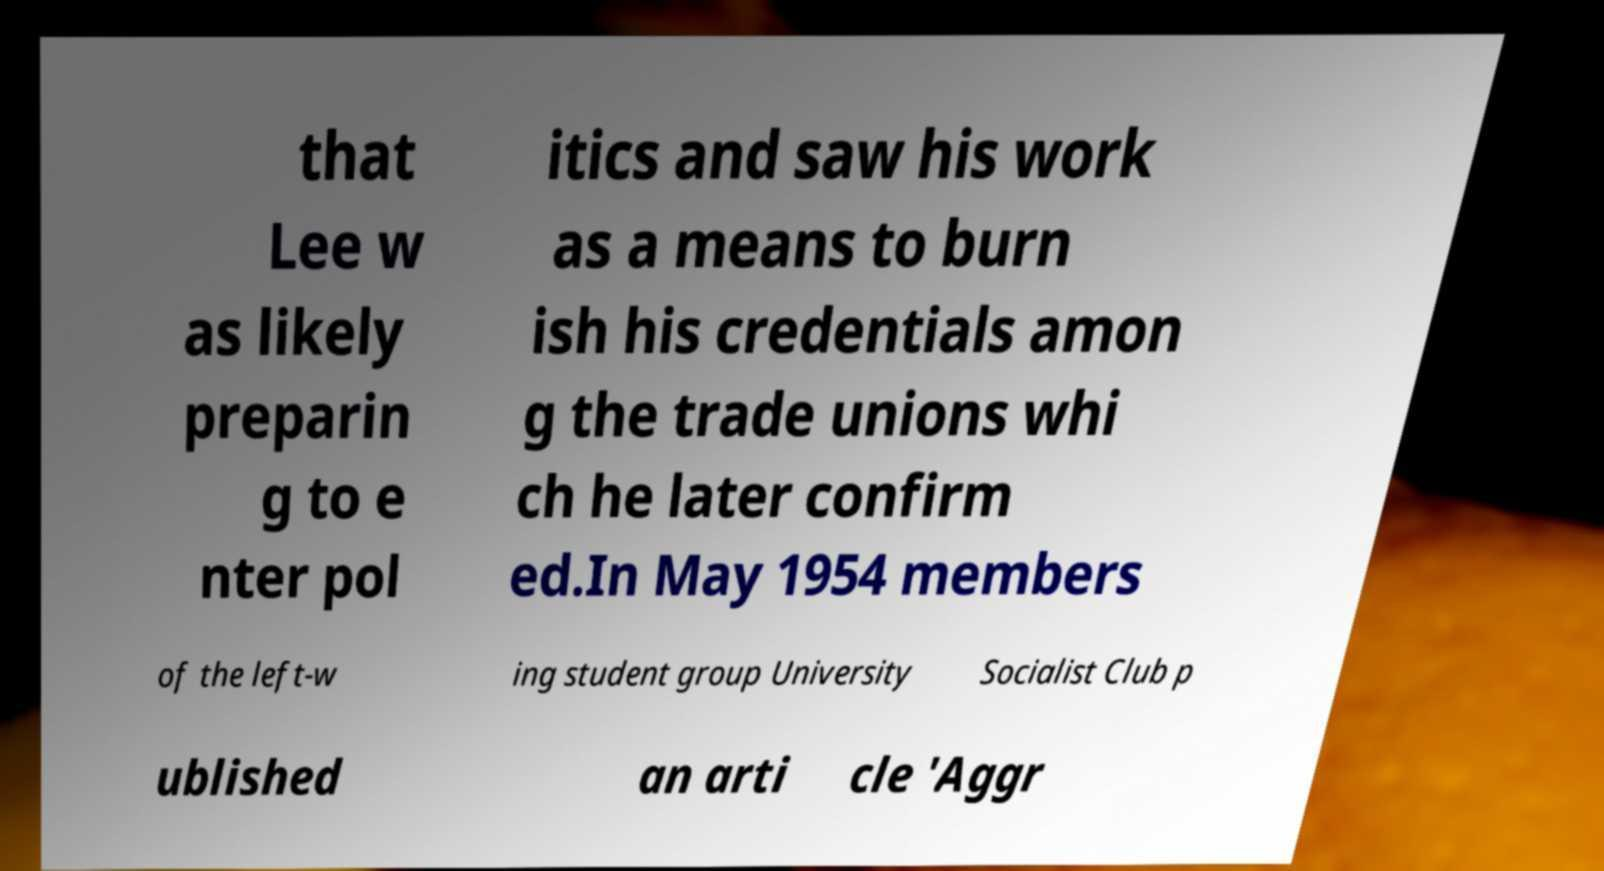Can you accurately transcribe the text from the provided image for me? that Lee w as likely preparin g to e nter pol itics and saw his work as a means to burn ish his credentials amon g the trade unions whi ch he later confirm ed.In May 1954 members of the left-w ing student group University Socialist Club p ublished an arti cle 'Aggr 